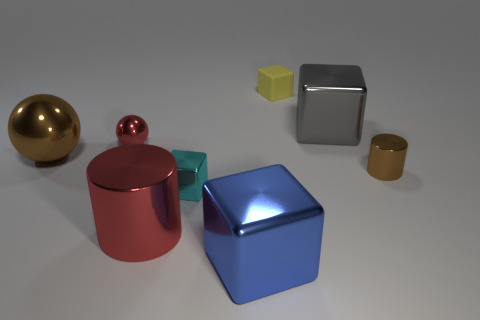Add 2 tiny metallic balls. How many objects exist? 10 Subtract all balls. How many objects are left? 6 Add 2 large things. How many large things exist? 6 Subtract 0 gray spheres. How many objects are left? 8 Subtract all cyan metal cylinders. Subtract all shiny cylinders. How many objects are left? 6 Add 8 blue metal cubes. How many blue metal cubes are left? 9 